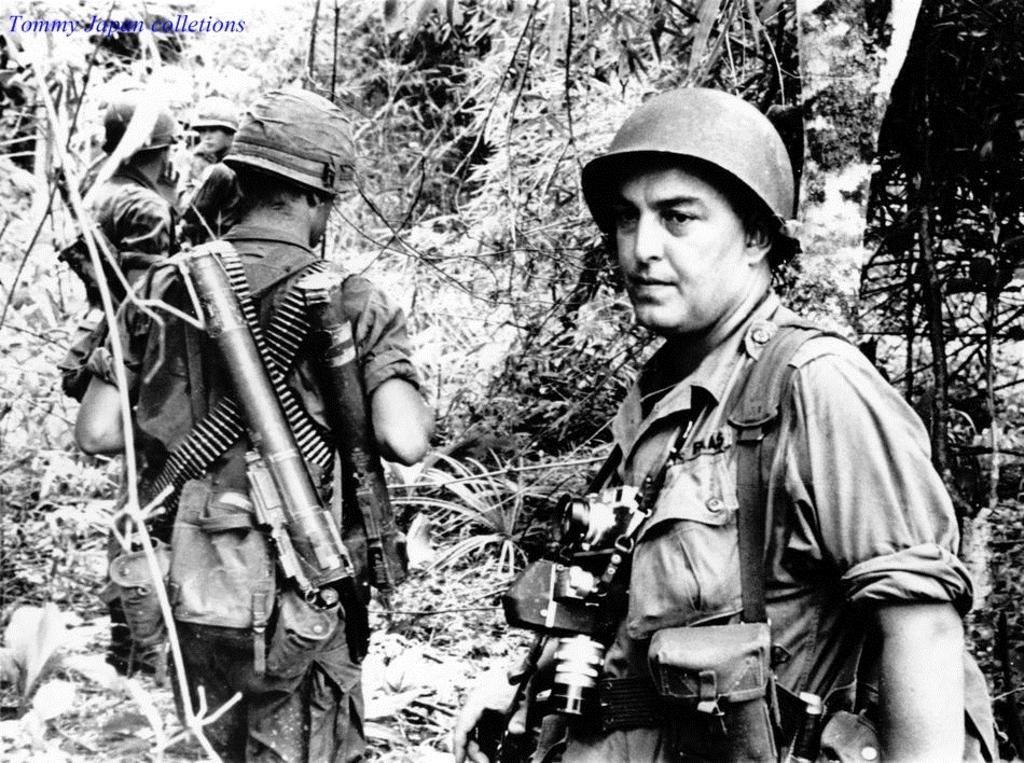What is the color scheme of the image? The image is black and white. How many people are in the image? There are two persons in the center of the image. What are the persons wearing? The persons are wearing helmets. What are the persons holding in the image? The persons are carrying weapons. What can be seen in the background of the image? There are trees in the background of the image. How many cars are parked near the persons in the image? There are no cars present in the image; it features two persons wearing helmets and carrying weapons in a setting with trees in the background. Can you see a cow grazing in the background of the image? There is no cow present in the image; it features two persons wearing helmets and carrying weapons in a setting with trees in the background. 